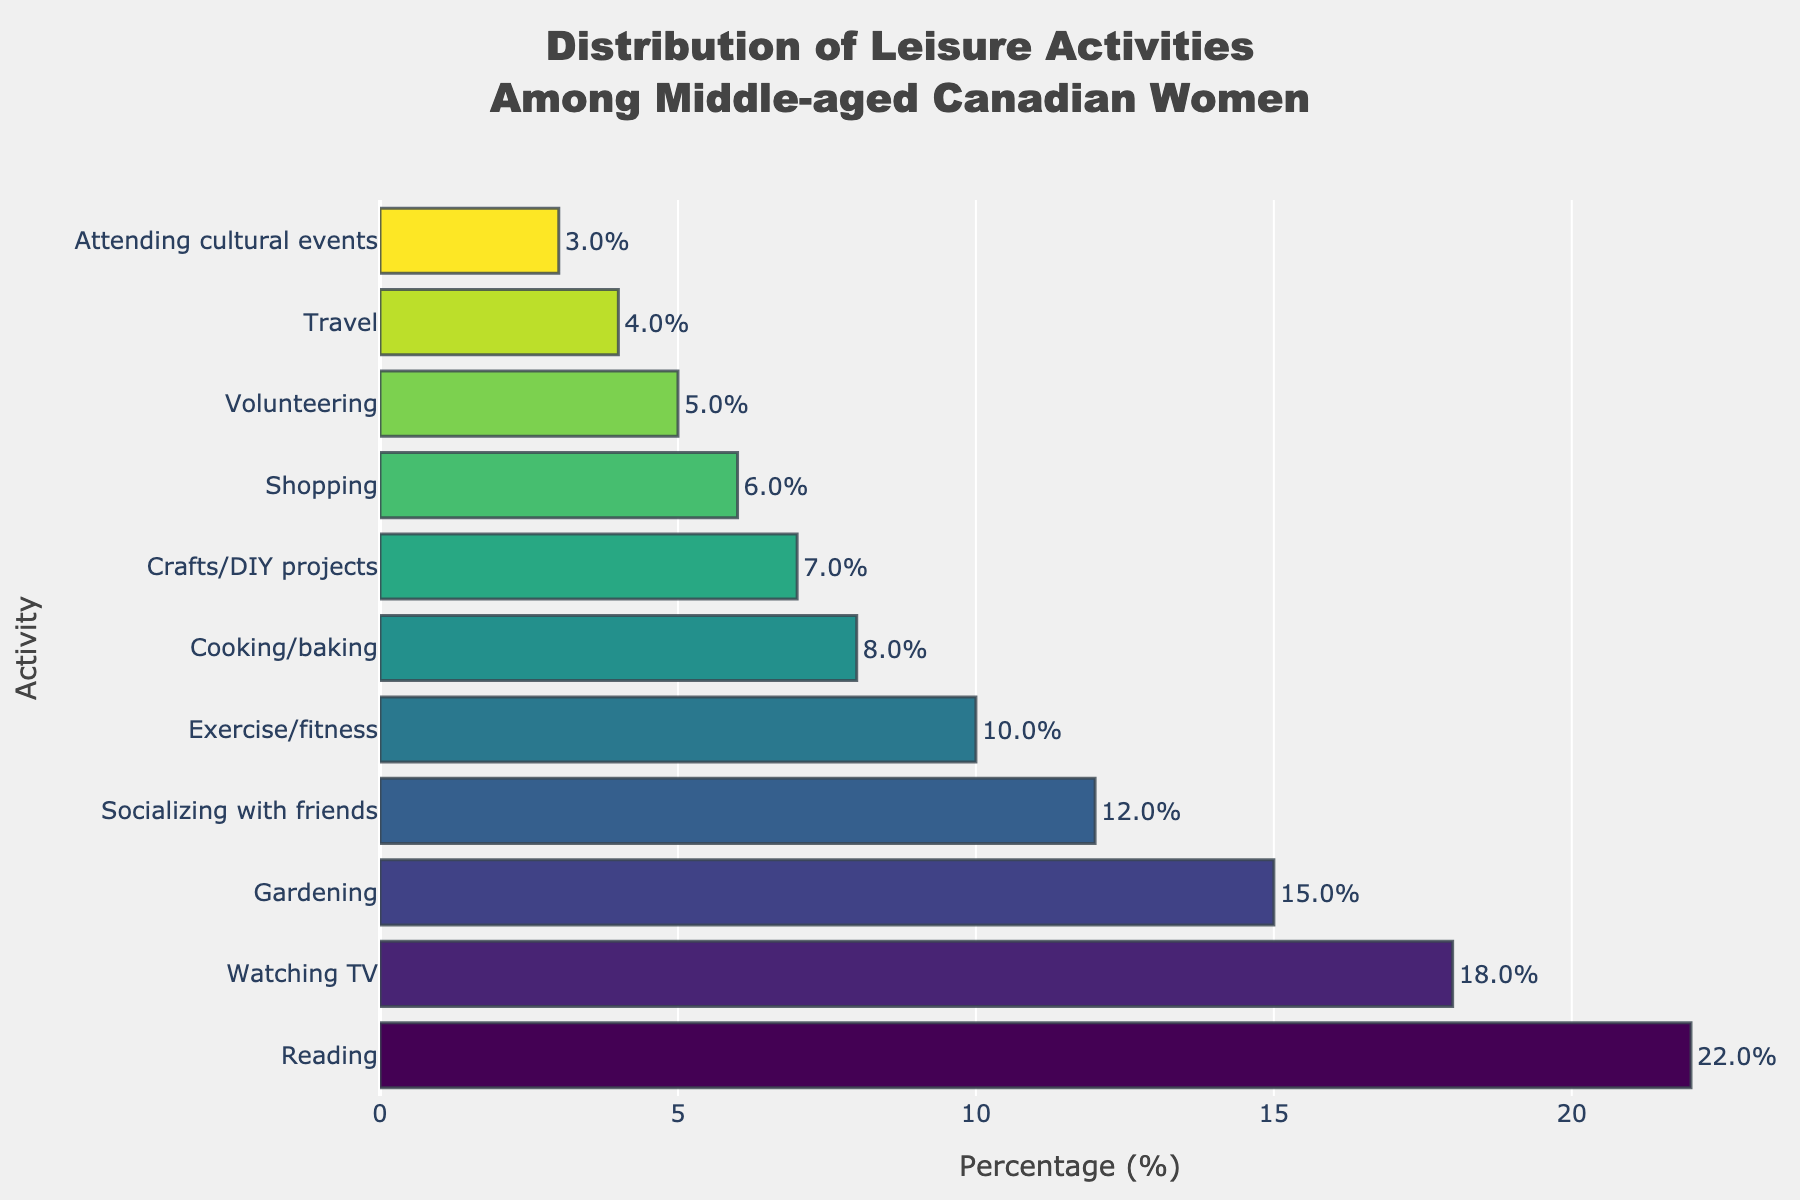Which leisure activity has the highest percentage among middle-aged Canadian women? By looking at the bar chart, the length of bars can be compared to determine which activity has the highest percentage. The longest bar corresponds to "Reading" with 22%.
Answer: Reading How much higher is the percentage of women who enjoy reading compared to those who enjoy gardening? By finding the percentage values of reading and gardening from the chart, we can then subtract the latter from the former. Reading is 22% and gardening is 15%, so 22% - 15% = 7%.
Answer: 7% If we combine the percentages of women who participate in cooking/baking and crafts/DIY projects, how much would that be? We need to sum the percentages of cooking/baking and crafts/DIY projects from the chart. Cooking/baking is 8% and crafts/DIY projects is 7%, so 8% + 7% = 15%.
Answer: 15% Which two leisure activities have the smallest difference in their percentages? We compare the percentages of all activities and find the two closest values. Socializing with friends (12%) and exercise/fitness (10%) have the smallest difference. 12% - 10% = 2%.
Answer: Socializing with friends and Exercise/fitness How much greater is the percentage of women who watch TV compared to those who volunteer? We subtract the percentage of volunteering from the percentage of watching TV. Watching TV is 18% and volunteering is 5%, so 18% - 5% = 13%.
Answer: 13% What is the total percentage of women who engage in exercise/fitness, shopping, and travel combined? We sum the percentages of these three activities from the chart. Exercise/fitness is 10%, shopping is 6%, and travel is 4%, so 10% + 6% + 4% = 20%.
Answer: 20% Which activity has a percentage closest to the average percentage of all listed activities? First, calculate the average percentage of all activities. Sum all percentages: 22 + 18 + 15 + 12 + 10 + 8 + 7 + 6 + 5 + 4 + 3 = 110, then divide by the number of activities (11), so 110/11 ≈ 10%. Exercise/fitness, which is 10%, is closest to the average.
Answer: Exercise/fitness How do the lengths of the bars representing exercise/fitness and cooking/baking compare? By visual observation, the bar for exercise/fitness is longer than the bar for cooking/baking. Exercise/fitness is at 10% while cooking/baking is at 8%.
Answer: Exercise/fitness is longer What is the difference between the highest and lowest percentages of activities? The highest percentage is Reading at 22% and the lowest is Attending cultural events at 3%. Subtract the smallest from the largest: 22% - 3% = 19%.
Answer: 19% If the percentages for socializing with friends and shopping were to be doubled, would either exceed the percentage for reading? Doubling the percentage of socializing with friends gives 12% * 2 = 24% and shopping gives 6% * 2 = 12%. Comparing with reading's 22%, socializing with friends would exceed it (24%) while shopping would not (12%).
Answer: Only socializing with friends would exceed 